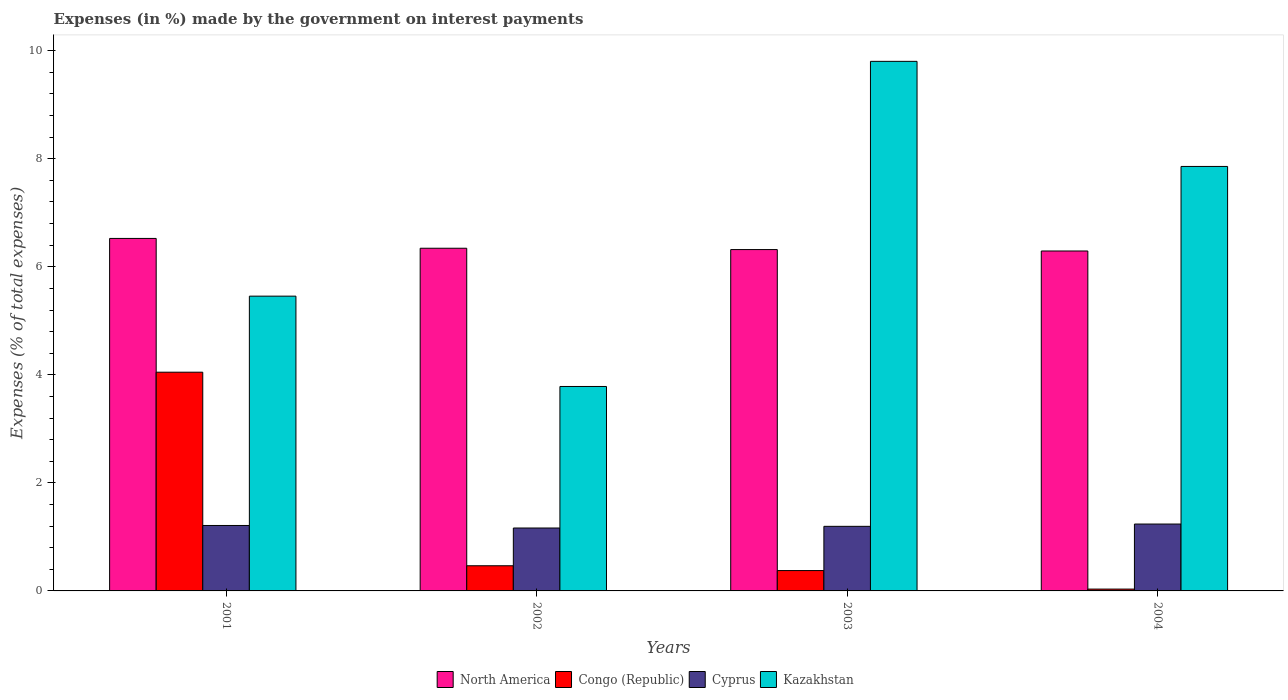Are the number of bars on each tick of the X-axis equal?
Your answer should be compact. Yes. How many bars are there on the 3rd tick from the right?
Your answer should be very brief. 4. What is the label of the 3rd group of bars from the left?
Keep it short and to the point. 2003. What is the percentage of expenses made by the government on interest payments in Kazakhstan in 2004?
Ensure brevity in your answer.  7.86. Across all years, what is the maximum percentage of expenses made by the government on interest payments in North America?
Provide a succinct answer. 6.53. Across all years, what is the minimum percentage of expenses made by the government on interest payments in Kazakhstan?
Your response must be concise. 3.78. In which year was the percentage of expenses made by the government on interest payments in North America maximum?
Provide a succinct answer. 2001. What is the total percentage of expenses made by the government on interest payments in Kazakhstan in the graph?
Make the answer very short. 26.9. What is the difference between the percentage of expenses made by the government on interest payments in Congo (Republic) in 2001 and that in 2002?
Give a very brief answer. 3.58. What is the difference between the percentage of expenses made by the government on interest payments in Kazakhstan in 2002 and the percentage of expenses made by the government on interest payments in North America in 2004?
Ensure brevity in your answer.  -2.51. What is the average percentage of expenses made by the government on interest payments in North America per year?
Make the answer very short. 6.37. In the year 2002, what is the difference between the percentage of expenses made by the government on interest payments in Kazakhstan and percentage of expenses made by the government on interest payments in North America?
Keep it short and to the point. -2.56. What is the ratio of the percentage of expenses made by the government on interest payments in Kazakhstan in 2001 to that in 2004?
Keep it short and to the point. 0.69. Is the difference between the percentage of expenses made by the government on interest payments in Kazakhstan in 2003 and 2004 greater than the difference between the percentage of expenses made by the government on interest payments in North America in 2003 and 2004?
Keep it short and to the point. Yes. What is the difference between the highest and the second highest percentage of expenses made by the government on interest payments in Kazakhstan?
Your response must be concise. 1.95. What is the difference between the highest and the lowest percentage of expenses made by the government on interest payments in Congo (Republic)?
Offer a terse response. 4.02. Is the sum of the percentage of expenses made by the government on interest payments in Cyprus in 2001 and 2002 greater than the maximum percentage of expenses made by the government on interest payments in North America across all years?
Make the answer very short. No. What does the 4th bar from the left in 2001 represents?
Give a very brief answer. Kazakhstan. What does the 2nd bar from the right in 2001 represents?
Make the answer very short. Cyprus. Are all the bars in the graph horizontal?
Offer a very short reply. No. How many years are there in the graph?
Your response must be concise. 4. Does the graph contain grids?
Make the answer very short. No. What is the title of the graph?
Ensure brevity in your answer.  Expenses (in %) made by the government on interest payments. Does "Azerbaijan" appear as one of the legend labels in the graph?
Give a very brief answer. No. What is the label or title of the Y-axis?
Provide a succinct answer. Expenses (% of total expenses). What is the Expenses (% of total expenses) in North America in 2001?
Provide a succinct answer. 6.53. What is the Expenses (% of total expenses) of Congo (Republic) in 2001?
Give a very brief answer. 4.05. What is the Expenses (% of total expenses) in Cyprus in 2001?
Provide a succinct answer. 1.21. What is the Expenses (% of total expenses) of Kazakhstan in 2001?
Make the answer very short. 5.46. What is the Expenses (% of total expenses) of North America in 2002?
Ensure brevity in your answer.  6.34. What is the Expenses (% of total expenses) of Congo (Republic) in 2002?
Provide a short and direct response. 0.47. What is the Expenses (% of total expenses) of Cyprus in 2002?
Your response must be concise. 1.16. What is the Expenses (% of total expenses) of Kazakhstan in 2002?
Make the answer very short. 3.78. What is the Expenses (% of total expenses) of North America in 2003?
Ensure brevity in your answer.  6.32. What is the Expenses (% of total expenses) in Congo (Republic) in 2003?
Ensure brevity in your answer.  0.38. What is the Expenses (% of total expenses) in Cyprus in 2003?
Keep it short and to the point. 1.2. What is the Expenses (% of total expenses) of Kazakhstan in 2003?
Your answer should be very brief. 9.8. What is the Expenses (% of total expenses) of North America in 2004?
Ensure brevity in your answer.  6.29. What is the Expenses (% of total expenses) in Congo (Republic) in 2004?
Offer a very short reply. 0.03. What is the Expenses (% of total expenses) of Cyprus in 2004?
Your answer should be compact. 1.24. What is the Expenses (% of total expenses) in Kazakhstan in 2004?
Offer a very short reply. 7.86. Across all years, what is the maximum Expenses (% of total expenses) in North America?
Your answer should be compact. 6.53. Across all years, what is the maximum Expenses (% of total expenses) of Congo (Republic)?
Ensure brevity in your answer.  4.05. Across all years, what is the maximum Expenses (% of total expenses) in Cyprus?
Offer a very short reply. 1.24. Across all years, what is the maximum Expenses (% of total expenses) in Kazakhstan?
Offer a terse response. 9.8. Across all years, what is the minimum Expenses (% of total expenses) in North America?
Keep it short and to the point. 6.29. Across all years, what is the minimum Expenses (% of total expenses) in Congo (Republic)?
Keep it short and to the point. 0.03. Across all years, what is the minimum Expenses (% of total expenses) in Cyprus?
Give a very brief answer. 1.16. Across all years, what is the minimum Expenses (% of total expenses) of Kazakhstan?
Provide a short and direct response. 3.78. What is the total Expenses (% of total expenses) of North America in the graph?
Your answer should be very brief. 25.48. What is the total Expenses (% of total expenses) of Congo (Republic) in the graph?
Offer a very short reply. 4.93. What is the total Expenses (% of total expenses) in Cyprus in the graph?
Offer a very short reply. 4.81. What is the total Expenses (% of total expenses) of Kazakhstan in the graph?
Your answer should be very brief. 26.9. What is the difference between the Expenses (% of total expenses) of North America in 2001 and that in 2002?
Offer a terse response. 0.18. What is the difference between the Expenses (% of total expenses) in Congo (Republic) in 2001 and that in 2002?
Your response must be concise. 3.58. What is the difference between the Expenses (% of total expenses) of Cyprus in 2001 and that in 2002?
Your answer should be compact. 0.05. What is the difference between the Expenses (% of total expenses) of Kazakhstan in 2001 and that in 2002?
Your answer should be very brief. 1.67. What is the difference between the Expenses (% of total expenses) of North America in 2001 and that in 2003?
Your answer should be very brief. 0.21. What is the difference between the Expenses (% of total expenses) in Congo (Republic) in 2001 and that in 2003?
Your response must be concise. 3.67. What is the difference between the Expenses (% of total expenses) of Cyprus in 2001 and that in 2003?
Keep it short and to the point. 0.02. What is the difference between the Expenses (% of total expenses) in Kazakhstan in 2001 and that in 2003?
Provide a short and direct response. -4.35. What is the difference between the Expenses (% of total expenses) in North America in 2001 and that in 2004?
Offer a terse response. 0.23. What is the difference between the Expenses (% of total expenses) of Congo (Republic) in 2001 and that in 2004?
Your answer should be very brief. 4.02. What is the difference between the Expenses (% of total expenses) of Cyprus in 2001 and that in 2004?
Give a very brief answer. -0.03. What is the difference between the Expenses (% of total expenses) of Kazakhstan in 2001 and that in 2004?
Offer a terse response. -2.4. What is the difference between the Expenses (% of total expenses) of North America in 2002 and that in 2003?
Give a very brief answer. 0.02. What is the difference between the Expenses (% of total expenses) of Congo (Republic) in 2002 and that in 2003?
Your response must be concise. 0.09. What is the difference between the Expenses (% of total expenses) in Cyprus in 2002 and that in 2003?
Give a very brief answer. -0.03. What is the difference between the Expenses (% of total expenses) in Kazakhstan in 2002 and that in 2003?
Your answer should be very brief. -6.02. What is the difference between the Expenses (% of total expenses) of North America in 2002 and that in 2004?
Offer a terse response. 0.05. What is the difference between the Expenses (% of total expenses) in Congo (Republic) in 2002 and that in 2004?
Keep it short and to the point. 0.43. What is the difference between the Expenses (% of total expenses) in Cyprus in 2002 and that in 2004?
Ensure brevity in your answer.  -0.07. What is the difference between the Expenses (% of total expenses) in Kazakhstan in 2002 and that in 2004?
Your answer should be very brief. -4.07. What is the difference between the Expenses (% of total expenses) of North America in 2003 and that in 2004?
Make the answer very short. 0.03. What is the difference between the Expenses (% of total expenses) in Congo (Republic) in 2003 and that in 2004?
Your answer should be very brief. 0.34. What is the difference between the Expenses (% of total expenses) in Cyprus in 2003 and that in 2004?
Ensure brevity in your answer.  -0.04. What is the difference between the Expenses (% of total expenses) of Kazakhstan in 2003 and that in 2004?
Offer a terse response. 1.95. What is the difference between the Expenses (% of total expenses) of North America in 2001 and the Expenses (% of total expenses) of Congo (Republic) in 2002?
Your response must be concise. 6.06. What is the difference between the Expenses (% of total expenses) of North America in 2001 and the Expenses (% of total expenses) of Cyprus in 2002?
Your answer should be compact. 5.36. What is the difference between the Expenses (% of total expenses) in North America in 2001 and the Expenses (% of total expenses) in Kazakhstan in 2002?
Keep it short and to the point. 2.74. What is the difference between the Expenses (% of total expenses) of Congo (Republic) in 2001 and the Expenses (% of total expenses) of Cyprus in 2002?
Give a very brief answer. 2.88. What is the difference between the Expenses (% of total expenses) of Congo (Republic) in 2001 and the Expenses (% of total expenses) of Kazakhstan in 2002?
Make the answer very short. 0.26. What is the difference between the Expenses (% of total expenses) in Cyprus in 2001 and the Expenses (% of total expenses) in Kazakhstan in 2002?
Offer a terse response. -2.57. What is the difference between the Expenses (% of total expenses) in North America in 2001 and the Expenses (% of total expenses) in Congo (Republic) in 2003?
Ensure brevity in your answer.  6.15. What is the difference between the Expenses (% of total expenses) of North America in 2001 and the Expenses (% of total expenses) of Cyprus in 2003?
Provide a succinct answer. 5.33. What is the difference between the Expenses (% of total expenses) of North America in 2001 and the Expenses (% of total expenses) of Kazakhstan in 2003?
Make the answer very short. -3.28. What is the difference between the Expenses (% of total expenses) of Congo (Republic) in 2001 and the Expenses (% of total expenses) of Cyprus in 2003?
Offer a terse response. 2.85. What is the difference between the Expenses (% of total expenses) in Congo (Republic) in 2001 and the Expenses (% of total expenses) in Kazakhstan in 2003?
Offer a very short reply. -5.75. What is the difference between the Expenses (% of total expenses) in Cyprus in 2001 and the Expenses (% of total expenses) in Kazakhstan in 2003?
Provide a succinct answer. -8.59. What is the difference between the Expenses (% of total expenses) of North America in 2001 and the Expenses (% of total expenses) of Congo (Republic) in 2004?
Keep it short and to the point. 6.49. What is the difference between the Expenses (% of total expenses) of North America in 2001 and the Expenses (% of total expenses) of Cyprus in 2004?
Ensure brevity in your answer.  5.29. What is the difference between the Expenses (% of total expenses) of North America in 2001 and the Expenses (% of total expenses) of Kazakhstan in 2004?
Make the answer very short. -1.33. What is the difference between the Expenses (% of total expenses) in Congo (Republic) in 2001 and the Expenses (% of total expenses) in Cyprus in 2004?
Keep it short and to the point. 2.81. What is the difference between the Expenses (% of total expenses) in Congo (Republic) in 2001 and the Expenses (% of total expenses) in Kazakhstan in 2004?
Your answer should be very brief. -3.81. What is the difference between the Expenses (% of total expenses) of Cyprus in 2001 and the Expenses (% of total expenses) of Kazakhstan in 2004?
Provide a succinct answer. -6.65. What is the difference between the Expenses (% of total expenses) in North America in 2002 and the Expenses (% of total expenses) in Congo (Republic) in 2003?
Your answer should be compact. 5.97. What is the difference between the Expenses (% of total expenses) in North America in 2002 and the Expenses (% of total expenses) in Cyprus in 2003?
Provide a succinct answer. 5.15. What is the difference between the Expenses (% of total expenses) in North America in 2002 and the Expenses (% of total expenses) in Kazakhstan in 2003?
Keep it short and to the point. -3.46. What is the difference between the Expenses (% of total expenses) of Congo (Republic) in 2002 and the Expenses (% of total expenses) of Cyprus in 2003?
Your answer should be compact. -0.73. What is the difference between the Expenses (% of total expenses) of Congo (Republic) in 2002 and the Expenses (% of total expenses) of Kazakhstan in 2003?
Your response must be concise. -9.34. What is the difference between the Expenses (% of total expenses) in Cyprus in 2002 and the Expenses (% of total expenses) in Kazakhstan in 2003?
Offer a very short reply. -8.64. What is the difference between the Expenses (% of total expenses) in North America in 2002 and the Expenses (% of total expenses) in Congo (Republic) in 2004?
Make the answer very short. 6.31. What is the difference between the Expenses (% of total expenses) in North America in 2002 and the Expenses (% of total expenses) in Cyprus in 2004?
Your answer should be compact. 5.11. What is the difference between the Expenses (% of total expenses) of North America in 2002 and the Expenses (% of total expenses) of Kazakhstan in 2004?
Give a very brief answer. -1.51. What is the difference between the Expenses (% of total expenses) in Congo (Republic) in 2002 and the Expenses (% of total expenses) in Cyprus in 2004?
Your response must be concise. -0.77. What is the difference between the Expenses (% of total expenses) of Congo (Republic) in 2002 and the Expenses (% of total expenses) of Kazakhstan in 2004?
Keep it short and to the point. -7.39. What is the difference between the Expenses (% of total expenses) in Cyprus in 2002 and the Expenses (% of total expenses) in Kazakhstan in 2004?
Ensure brevity in your answer.  -6.69. What is the difference between the Expenses (% of total expenses) of North America in 2003 and the Expenses (% of total expenses) of Congo (Republic) in 2004?
Ensure brevity in your answer.  6.29. What is the difference between the Expenses (% of total expenses) in North America in 2003 and the Expenses (% of total expenses) in Cyprus in 2004?
Offer a very short reply. 5.08. What is the difference between the Expenses (% of total expenses) of North America in 2003 and the Expenses (% of total expenses) of Kazakhstan in 2004?
Provide a short and direct response. -1.54. What is the difference between the Expenses (% of total expenses) in Congo (Republic) in 2003 and the Expenses (% of total expenses) in Cyprus in 2004?
Provide a short and direct response. -0.86. What is the difference between the Expenses (% of total expenses) in Congo (Republic) in 2003 and the Expenses (% of total expenses) in Kazakhstan in 2004?
Offer a terse response. -7.48. What is the difference between the Expenses (% of total expenses) in Cyprus in 2003 and the Expenses (% of total expenses) in Kazakhstan in 2004?
Ensure brevity in your answer.  -6.66. What is the average Expenses (% of total expenses) of North America per year?
Ensure brevity in your answer.  6.37. What is the average Expenses (% of total expenses) in Congo (Republic) per year?
Provide a short and direct response. 1.23. What is the average Expenses (% of total expenses) of Cyprus per year?
Offer a terse response. 1.2. What is the average Expenses (% of total expenses) in Kazakhstan per year?
Keep it short and to the point. 6.73. In the year 2001, what is the difference between the Expenses (% of total expenses) of North America and Expenses (% of total expenses) of Congo (Republic)?
Offer a terse response. 2.48. In the year 2001, what is the difference between the Expenses (% of total expenses) in North America and Expenses (% of total expenses) in Cyprus?
Provide a succinct answer. 5.31. In the year 2001, what is the difference between the Expenses (% of total expenses) in North America and Expenses (% of total expenses) in Kazakhstan?
Give a very brief answer. 1.07. In the year 2001, what is the difference between the Expenses (% of total expenses) of Congo (Republic) and Expenses (% of total expenses) of Cyprus?
Provide a short and direct response. 2.84. In the year 2001, what is the difference between the Expenses (% of total expenses) in Congo (Republic) and Expenses (% of total expenses) in Kazakhstan?
Your answer should be very brief. -1.41. In the year 2001, what is the difference between the Expenses (% of total expenses) in Cyprus and Expenses (% of total expenses) in Kazakhstan?
Your response must be concise. -4.25. In the year 2002, what is the difference between the Expenses (% of total expenses) in North America and Expenses (% of total expenses) in Congo (Republic)?
Provide a succinct answer. 5.88. In the year 2002, what is the difference between the Expenses (% of total expenses) of North America and Expenses (% of total expenses) of Cyprus?
Keep it short and to the point. 5.18. In the year 2002, what is the difference between the Expenses (% of total expenses) in North America and Expenses (% of total expenses) in Kazakhstan?
Provide a short and direct response. 2.56. In the year 2002, what is the difference between the Expenses (% of total expenses) of Congo (Republic) and Expenses (% of total expenses) of Cyprus?
Provide a succinct answer. -0.7. In the year 2002, what is the difference between the Expenses (% of total expenses) in Congo (Republic) and Expenses (% of total expenses) in Kazakhstan?
Your response must be concise. -3.32. In the year 2002, what is the difference between the Expenses (% of total expenses) of Cyprus and Expenses (% of total expenses) of Kazakhstan?
Offer a very short reply. -2.62. In the year 2003, what is the difference between the Expenses (% of total expenses) of North America and Expenses (% of total expenses) of Congo (Republic)?
Offer a very short reply. 5.94. In the year 2003, what is the difference between the Expenses (% of total expenses) of North America and Expenses (% of total expenses) of Cyprus?
Give a very brief answer. 5.12. In the year 2003, what is the difference between the Expenses (% of total expenses) in North America and Expenses (% of total expenses) in Kazakhstan?
Your answer should be compact. -3.48. In the year 2003, what is the difference between the Expenses (% of total expenses) in Congo (Republic) and Expenses (% of total expenses) in Cyprus?
Ensure brevity in your answer.  -0.82. In the year 2003, what is the difference between the Expenses (% of total expenses) in Congo (Republic) and Expenses (% of total expenses) in Kazakhstan?
Offer a very short reply. -9.43. In the year 2003, what is the difference between the Expenses (% of total expenses) of Cyprus and Expenses (% of total expenses) of Kazakhstan?
Your answer should be very brief. -8.61. In the year 2004, what is the difference between the Expenses (% of total expenses) of North America and Expenses (% of total expenses) of Congo (Republic)?
Offer a terse response. 6.26. In the year 2004, what is the difference between the Expenses (% of total expenses) in North America and Expenses (% of total expenses) in Cyprus?
Your answer should be very brief. 5.06. In the year 2004, what is the difference between the Expenses (% of total expenses) of North America and Expenses (% of total expenses) of Kazakhstan?
Provide a succinct answer. -1.57. In the year 2004, what is the difference between the Expenses (% of total expenses) of Congo (Republic) and Expenses (% of total expenses) of Cyprus?
Ensure brevity in your answer.  -1.2. In the year 2004, what is the difference between the Expenses (% of total expenses) of Congo (Republic) and Expenses (% of total expenses) of Kazakhstan?
Your answer should be compact. -7.82. In the year 2004, what is the difference between the Expenses (% of total expenses) of Cyprus and Expenses (% of total expenses) of Kazakhstan?
Give a very brief answer. -6.62. What is the ratio of the Expenses (% of total expenses) in North America in 2001 to that in 2002?
Keep it short and to the point. 1.03. What is the ratio of the Expenses (% of total expenses) in Congo (Republic) in 2001 to that in 2002?
Give a very brief answer. 8.69. What is the ratio of the Expenses (% of total expenses) of Cyprus in 2001 to that in 2002?
Ensure brevity in your answer.  1.04. What is the ratio of the Expenses (% of total expenses) of Kazakhstan in 2001 to that in 2002?
Make the answer very short. 1.44. What is the ratio of the Expenses (% of total expenses) of North America in 2001 to that in 2003?
Ensure brevity in your answer.  1.03. What is the ratio of the Expenses (% of total expenses) of Congo (Republic) in 2001 to that in 2003?
Offer a very short reply. 10.75. What is the ratio of the Expenses (% of total expenses) of Cyprus in 2001 to that in 2003?
Provide a succinct answer. 1.01. What is the ratio of the Expenses (% of total expenses) in Kazakhstan in 2001 to that in 2003?
Provide a short and direct response. 0.56. What is the ratio of the Expenses (% of total expenses) in Congo (Republic) in 2001 to that in 2004?
Offer a terse response. 119.51. What is the ratio of the Expenses (% of total expenses) of Cyprus in 2001 to that in 2004?
Offer a terse response. 0.98. What is the ratio of the Expenses (% of total expenses) in Kazakhstan in 2001 to that in 2004?
Offer a very short reply. 0.69. What is the ratio of the Expenses (% of total expenses) in Congo (Republic) in 2002 to that in 2003?
Give a very brief answer. 1.24. What is the ratio of the Expenses (% of total expenses) of Cyprus in 2002 to that in 2003?
Ensure brevity in your answer.  0.97. What is the ratio of the Expenses (% of total expenses) in Kazakhstan in 2002 to that in 2003?
Offer a terse response. 0.39. What is the ratio of the Expenses (% of total expenses) of Congo (Republic) in 2002 to that in 2004?
Ensure brevity in your answer.  13.75. What is the ratio of the Expenses (% of total expenses) in Cyprus in 2002 to that in 2004?
Ensure brevity in your answer.  0.94. What is the ratio of the Expenses (% of total expenses) of Kazakhstan in 2002 to that in 2004?
Your response must be concise. 0.48. What is the ratio of the Expenses (% of total expenses) of North America in 2003 to that in 2004?
Your answer should be compact. 1. What is the ratio of the Expenses (% of total expenses) of Congo (Republic) in 2003 to that in 2004?
Keep it short and to the point. 11.12. What is the ratio of the Expenses (% of total expenses) of Cyprus in 2003 to that in 2004?
Your answer should be compact. 0.97. What is the ratio of the Expenses (% of total expenses) of Kazakhstan in 2003 to that in 2004?
Make the answer very short. 1.25. What is the difference between the highest and the second highest Expenses (% of total expenses) of North America?
Provide a short and direct response. 0.18. What is the difference between the highest and the second highest Expenses (% of total expenses) of Congo (Republic)?
Your answer should be compact. 3.58. What is the difference between the highest and the second highest Expenses (% of total expenses) of Cyprus?
Provide a succinct answer. 0.03. What is the difference between the highest and the second highest Expenses (% of total expenses) in Kazakhstan?
Make the answer very short. 1.95. What is the difference between the highest and the lowest Expenses (% of total expenses) in North America?
Provide a short and direct response. 0.23. What is the difference between the highest and the lowest Expenses (% of total expenses) in Congo (Republic)?
Your response must be concise. 4.02. What is the difference between the highest and the lowest Expenses (% of total expenses) of Cyprus?
Your answer should be compact. 0.07. What is the difference between the highest and the lowest Expenses (% of total expenses) of Kazakhstan?
Keep it short and to the point. 6.02. 